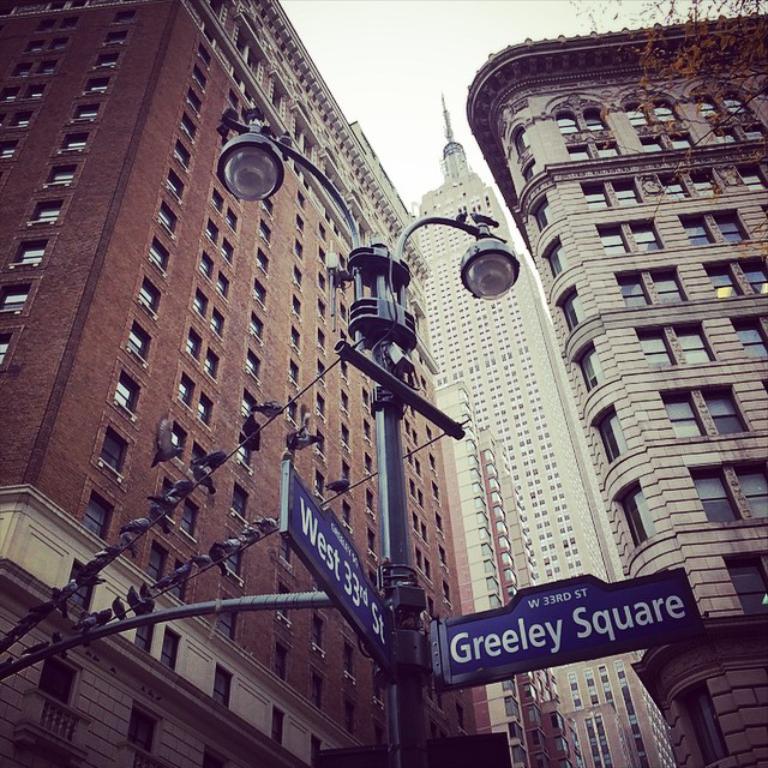In one or two sentences, can you explain what this image depicts? In this picture we can see the buildings. At the top of the image, there is the sky. In the top right corner of the image, there is a tree. At the bottom of the image, there is a pole with directional boards, cables and lights. There are birds on the cables. 